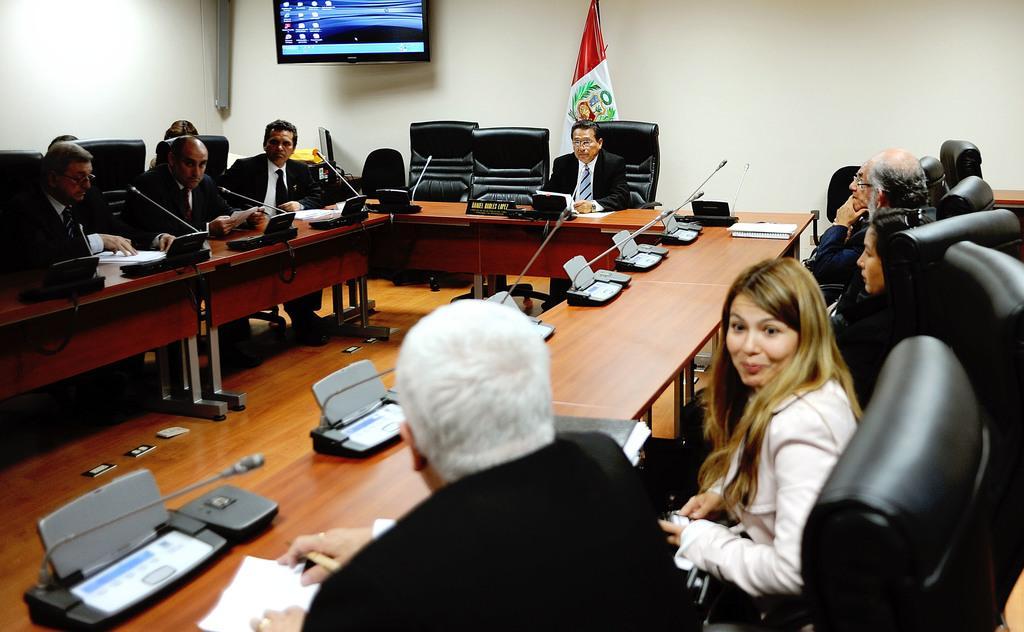How would you summarize this image in a sentence or two? i think this is a conference room all the people were seated in their chairs and we see a table with an microphone each and we see a monitor displaying and a flag 